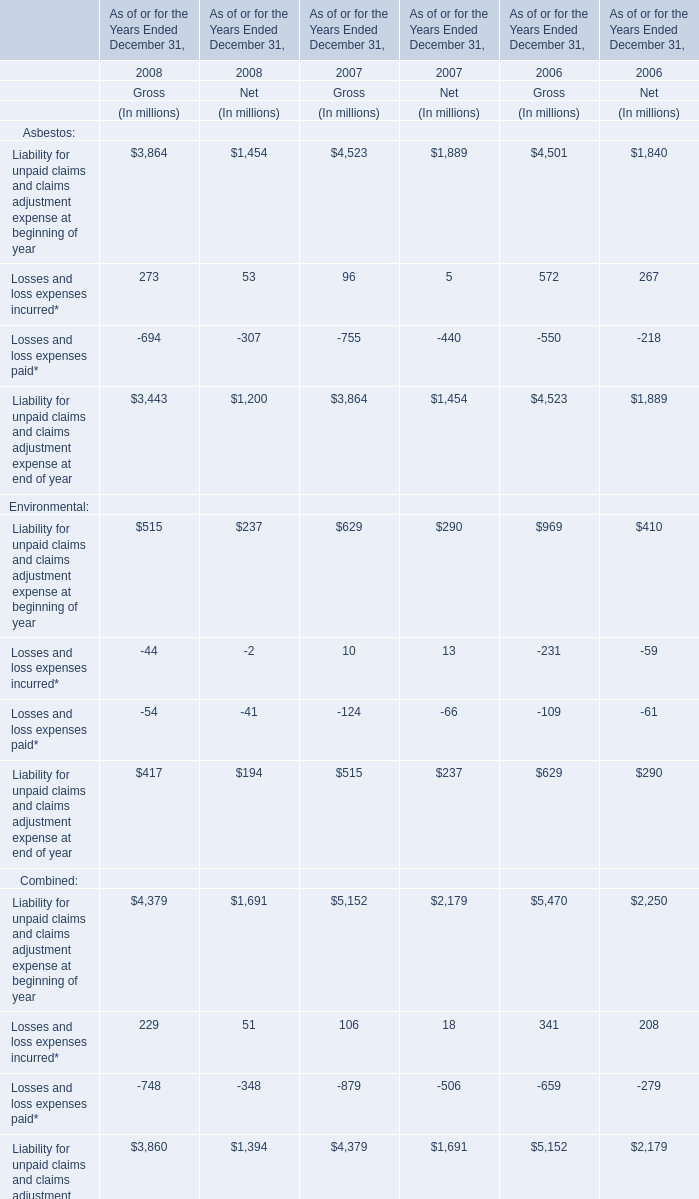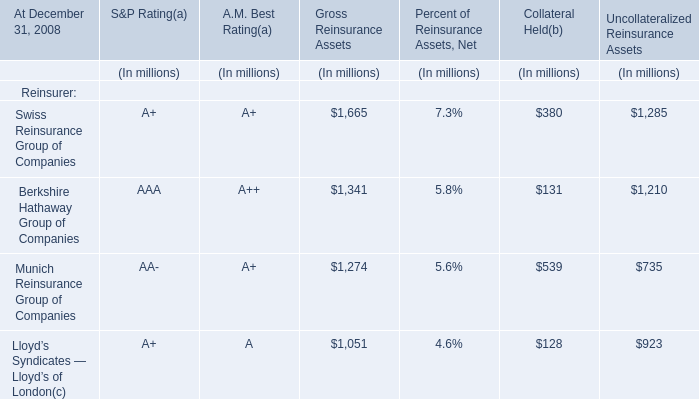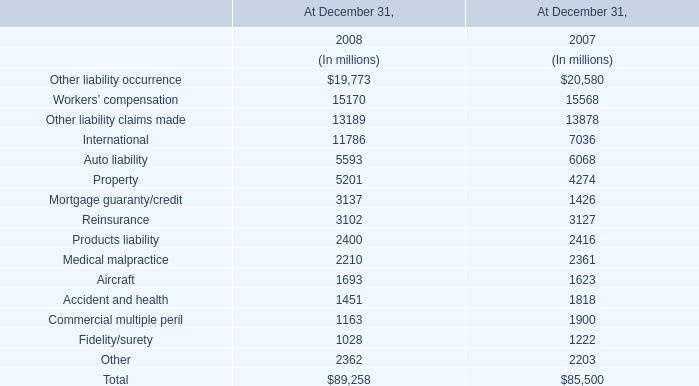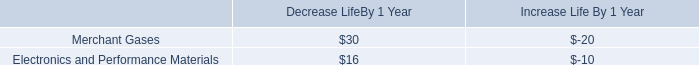What is the sum of Liability for unpaid claims and claims adjustment expense at beginning of year of Gross in 2008 and Property in 2007? (in millio) 
Computations: (515 + 4274)
Answer: 4789.0. 